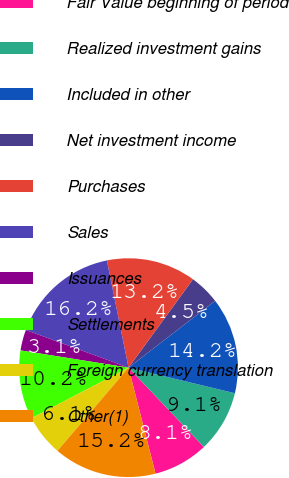<chart> <loc_0><loc_0><loc_500><loc_500><pie_chart><fcel>Fair Value beginning of period<fcel>Realized investment gains<fcel>Included in other<fcel>Net investment income<fcel>Purchases<fcel>Sales<fcel>Issuances<fcel>Settlements<fcel>Foreign currency translation<fcel>Other(1)<nl><fcel>8.13%<fcel>9.15%<fcel>14.21%<fcel>4.52%<fcel>13.2%<fcel>16.24%<fcel>3.07%<fcel>10.16%<fcel>6.11%<fcel>15.22%<nl></chart> 